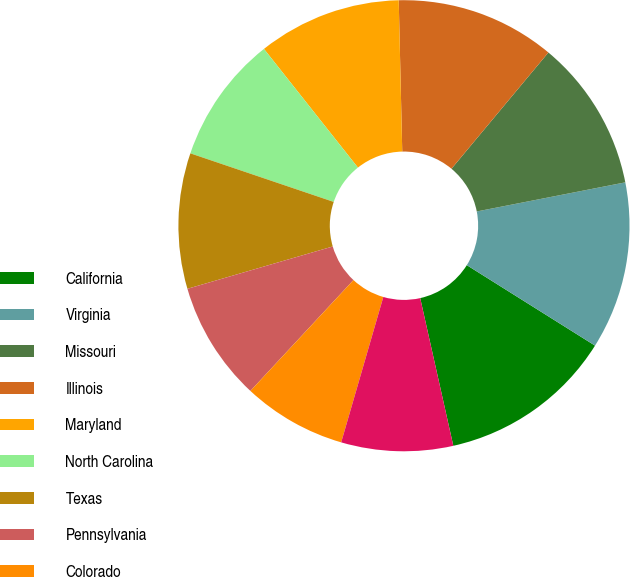Convert chart. <chart><loc_0><loc_0><loc_500><loc_500><pie_chart><fcel>California<fcel>Virginia<fcel>Missouri<fcel>Illinois<fcel>Maryland<fcel>North Carolina<fcel>Texas<fcel>Pennsylvania<fcel>Colorado<fcel>Florida<nl><fcel>12.57%<fcel>12.0%<fcel>10.86%<fcel>11.43%<fcel>10.29%<fcel>9.14%<fcel>9.71%<fcel>8.57%<fcel>7.43%<fcel>8.0%<nl></chart> 